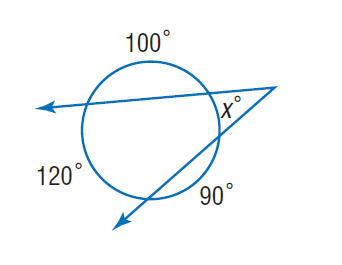Answer the mathemtical geometry problem and directly provide the correct option letter.
Question: Find x.
Choices: A: 35 B: 90 C: 100 D: 120 A 